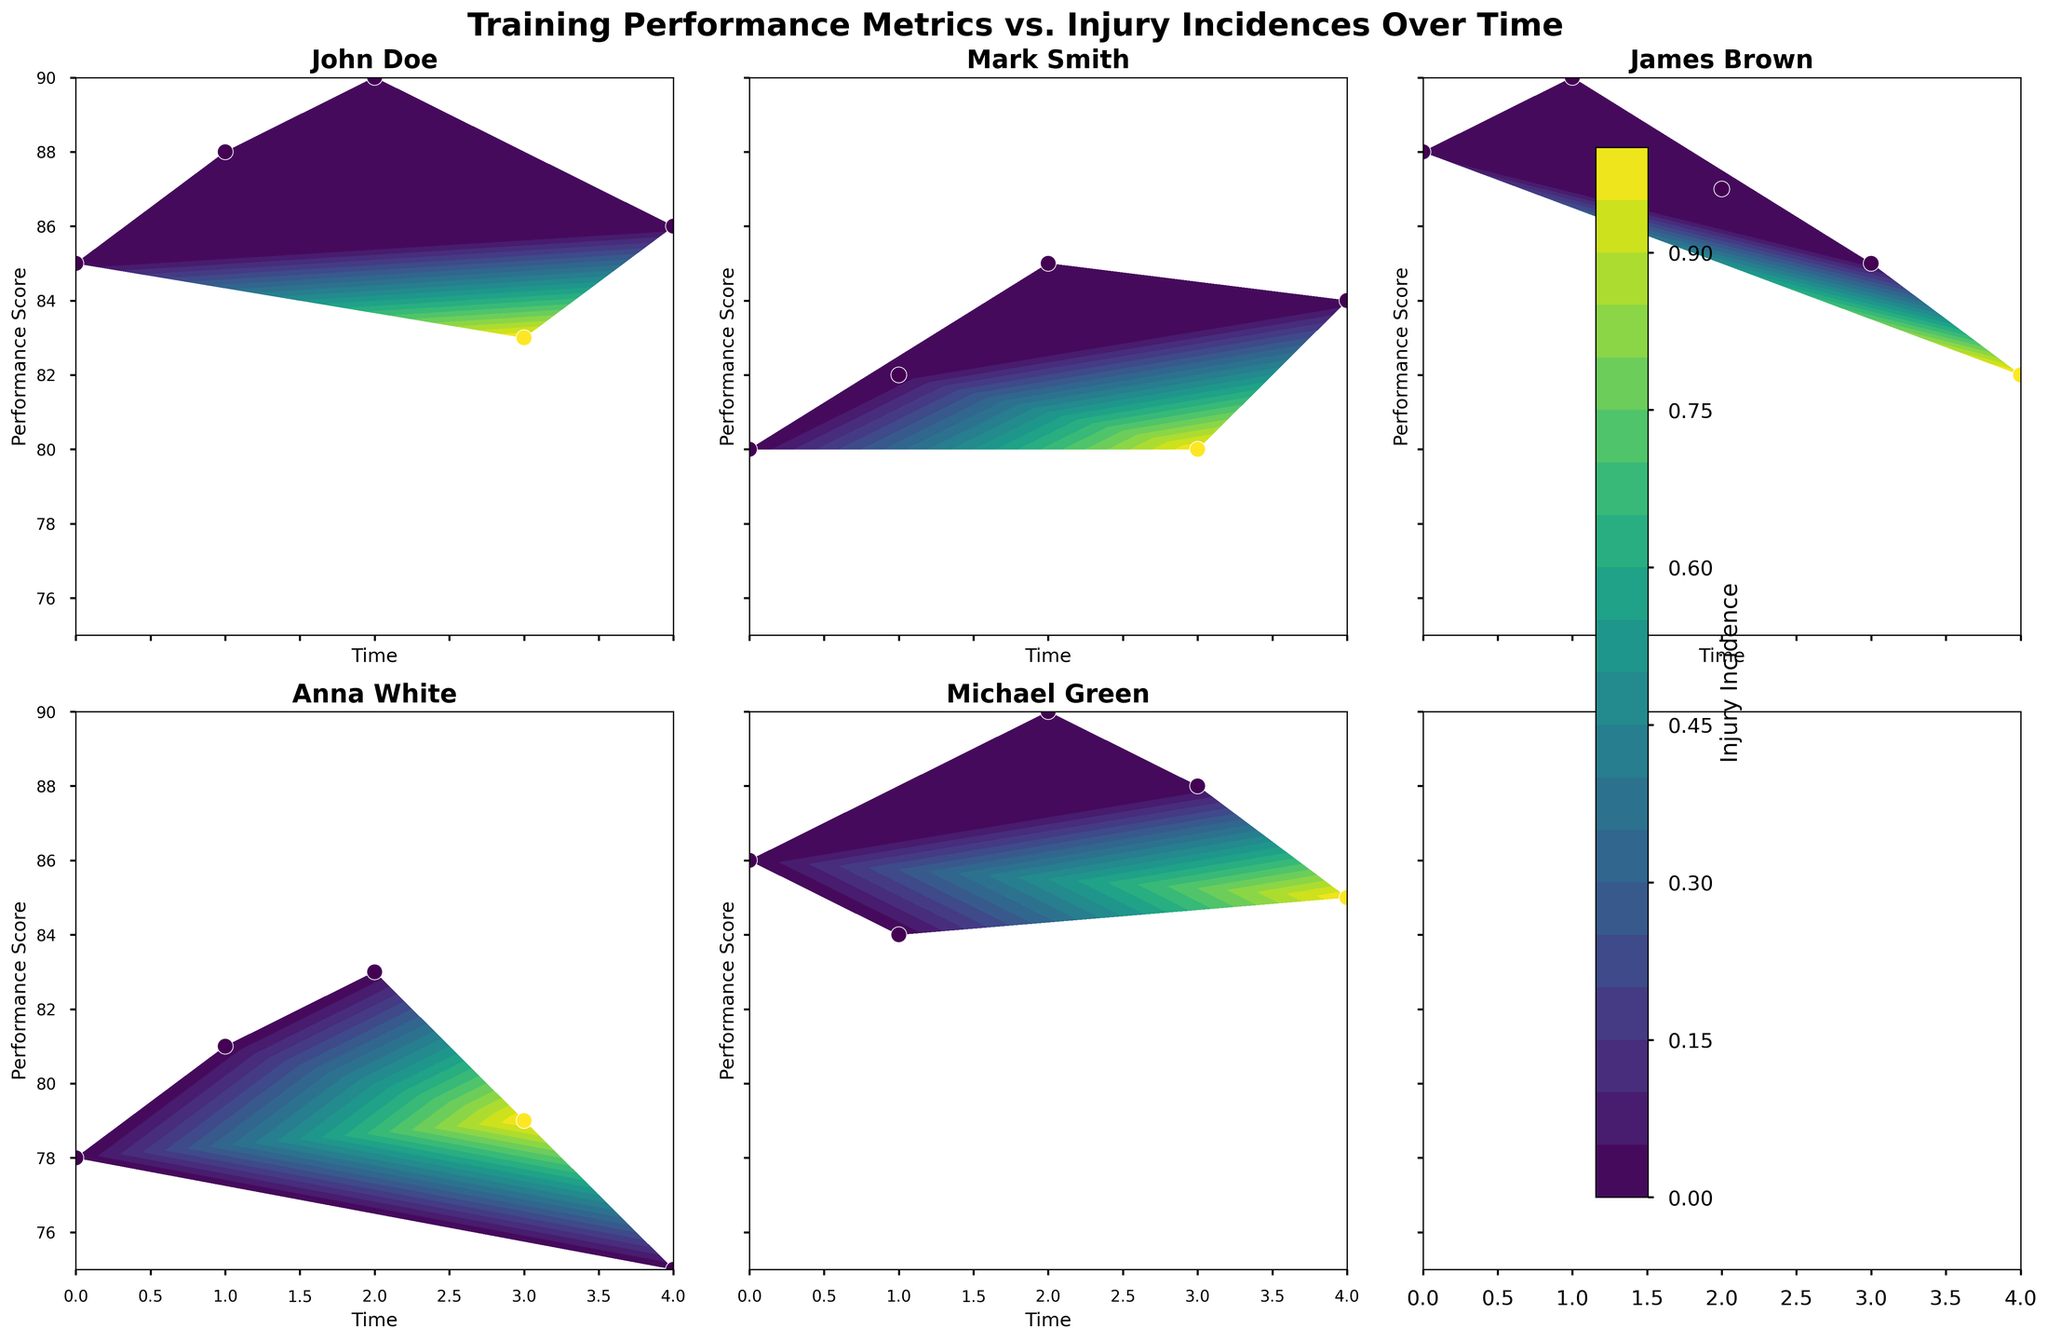How many players are represented in the figure? To determine the number of players, count the number of unique titles in the subplots. Each title represents a different player.
Answer: 5 Which player shows an injury incidence on day 3? Scan each subplot for points with Injury Incidence value greater than 0 on the x-axis value corresponding to day 3.
Answer: John Doe, Mark Smith, Anna White What is the color gradient used to represent injury incidence? Observe the color bar on the right side of the figure; it shows the gradient from low to high injury incidences.
Answer: Viridis Is there any player whose performance score decreases over time without any injury incidence? Analyze the trend line in each subplot where the Injury Incidence is zero throughout the timeline.
Answer: James Brown, Michael Green Compare the performance scores of Anna White and Mark Smith on day 4. Who has the higher score? Look at the point corresponding to day 4 in both Anna White's and Mark Smith's subplot and compare the Performance Scores.
Answer: Mark Smith Which player had the sharpest drop in performance score after an injury incident? Focus on players who have injury incidents and observe the changes in their performance scores following the injury. Compare the drops in scores.
Answer: Anna White How does the performance score trend for James Brown differ from John Doe? Compare the pattern or trend lines of performance scores over time for both players. Specifically, note rising, falling or any fluctuations.
Answer: James Brown's performance score decreases steadily while John Doe's fluctuates with a notable dip on day 4 Did Michael Green have a higher or lower performance score than Anna White on day 4? Locate the performance scores for both players on day 4 and compare.
Answer: Higher Which player consistently has the highest range of performance scores without injury until day 3? Check the range of performance scores from day 0 to day 3 for all players and evaluate those without injury incidents in this period.
Answer: James Brown 